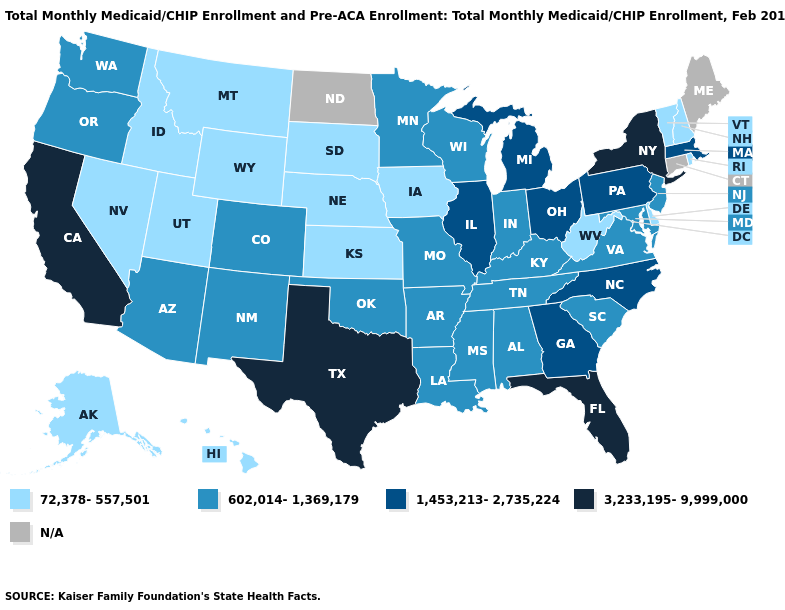What is the value of Colorado?
Concise answer only. 602,014-1,369,179. What is the lowest value in the USA?
Give a very brief answer. 72,378-557,501. What is the value of New York?
Quick response, please. 3,233,195-9,999,000. Is the legend a continuous bar?
Keep it brief. No. Which states hav the highest value in the South?
Write a very short answer. Florida, Texas. Does New York have the lowest value in the Northeast?
Give a very brief answer. No. How many symbols are there in the legend?
Write a very short answer. 5. Which states hav the highest value in the MidWest?
Concise answer only. Illinois, Michigan, Ohio. What is the lowest value in the South?
Short answer required. 72,378-557,501. What is the value of Kansas?
Quick response, please. 72,378-557,501. Which states have the lowest value in the USA?
Answer briefly. Alaska, Delaware, Hawaii, Idaho, Iowa, Kansas, Montana, Nebraska, Nevada, New Hampshire, Rhode Island, South Dakota, Utah, Vermont, West Virginia, Wyoming. Name the states that have a value in the range 1,453,213-2,735,224?
Give a very brief answer. Georgia, Illinois, Massachusetts, Michigan, North Carolina, Ohio, Pennsylvania. Does Missouri have the lowest value in the MidWest?
Keep it brief. No. 